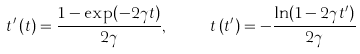<formula> <loc_0><loc_0><loc_500><loc_500>t ^ { \prime } \left ( t \right ) = \frac { 1 - \exp ( - 2 \gamma t ) } { 2 \gamma } , \quad \ t \left ( t ^ { \prime } \right ) = - \frac { \ln ( 1 - 2 \gamma t ^ { \prime } ) } { 2 \gamma }</formula> 